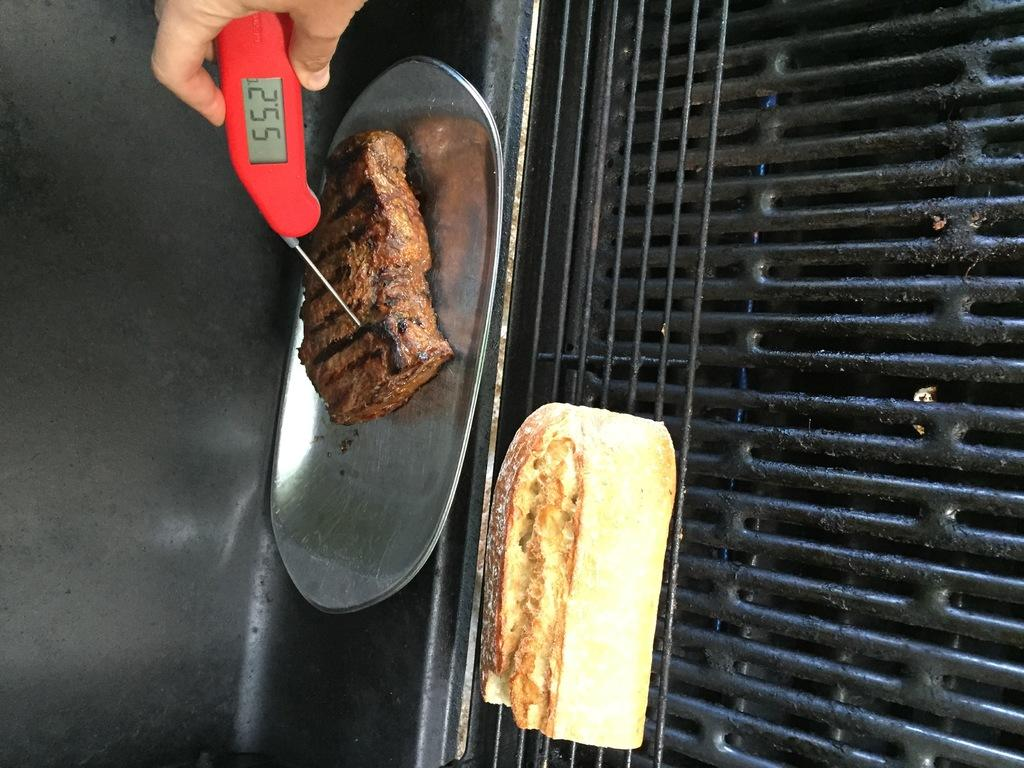What is on the plate in the image? There is a food item on the plate in the image. What is being cooked on the grill in the image? There is a food item on the grill in the image. What can be seen being held by a person's hand in the image? A person's hand is holding an object in the image. What type of headwear is the person wearing in the image? There is no headwear visible in the image; the focus is on the plate, grill, and hand holding an object. 